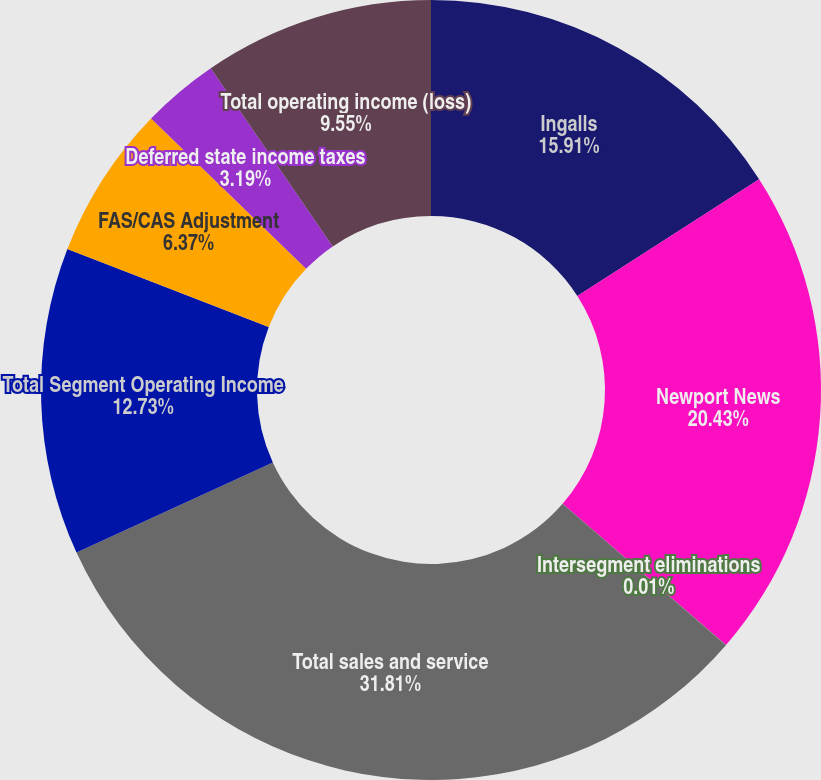<chart> <loc_0><loc_0><loc_500><loc_500><pie_chart><fcel>Ingalls<fcel>Newport News<fcel>Intersegment eliminations<fcel>Total sales and service<fcel>Total Segment Operating Income<fcel>FAS/CAS Adjustment<fcel>Deferred state income taxes<fcel>Total operating income (loss)<nl><fcel>15.91%<fcel>20.43%<fcel>0.01%<fcel>31.8%<fcel>12.73%<fcel>6.37%<fcel>3.19%<fcel>9.55%<nl></chart> 